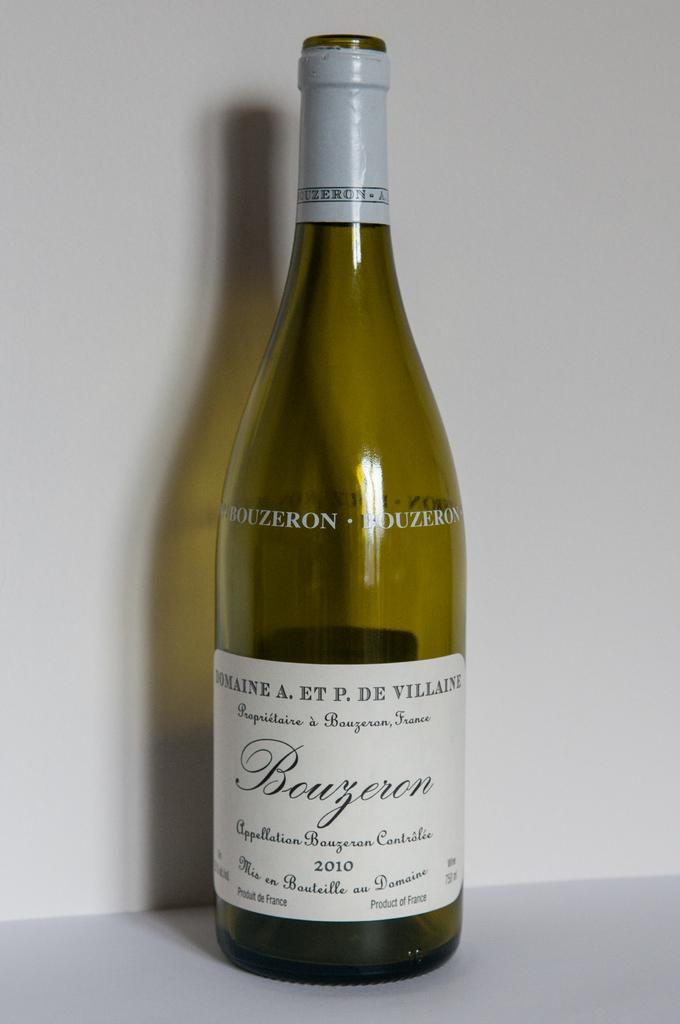In one or two sentences, can you explain what this image depicts? In this picture I can see a wine bottle with a label, on an object, and in the background there is a wall. 